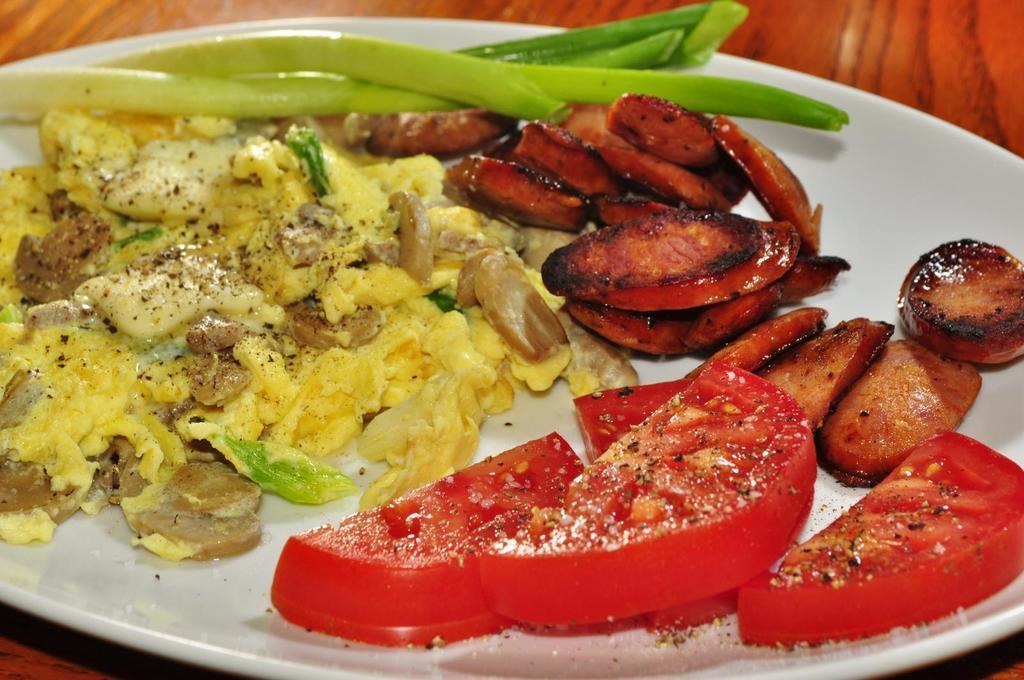Please provide a concise description of this image. In this picture I can see food in the plate and I can see a table. 